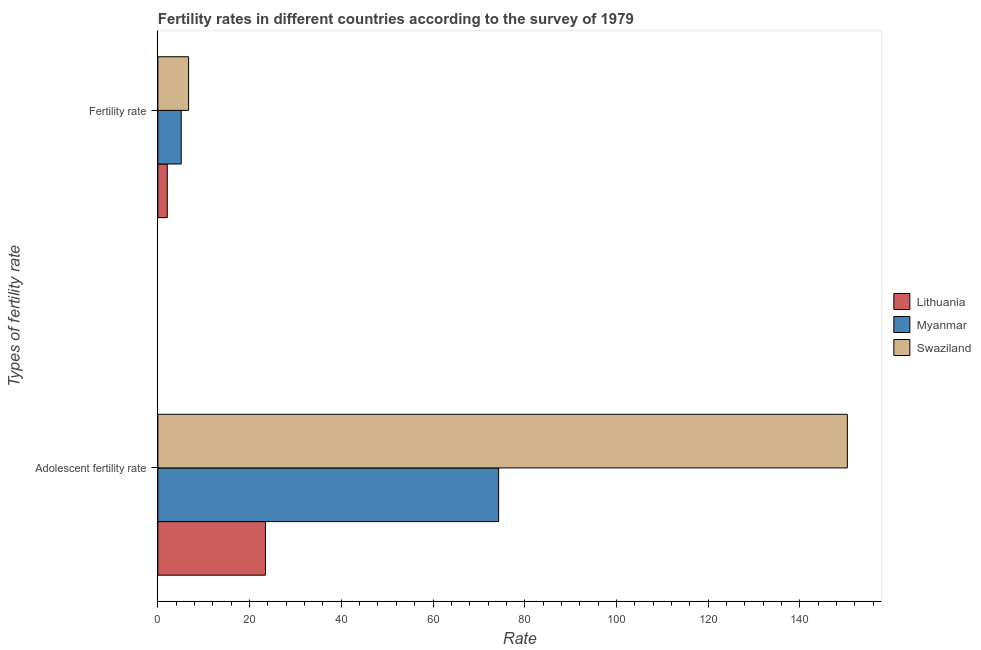How many groups of bars are there?
Provide a short and direct response. 2. Are the number of bars on each tick of the Y-axis equal?
Ensure brevity in your answer.  Yes. How many bars are there on the 1st tick from the top?
Provide a short and direct response. 3. How many bars are there on the 2nd tick from the bottom?
Ensure brevity in your answer.  3. What is the label of the 2nd group of bars from the top?
Offer a terse response. Adolescent fertility rate. What is the adolescent fertility rate in Lithuania?
Ensure brevity in your answer.  23.46. Across all countries, what is the maximum fertility rate?
Offer a very short reply. 6.7. Across all countries, what is the minimum adolescent fertility rate?
Offer a very short reply. 23.46. In which country was the fertility rate maximum?
Offer a very short reply. Swaziland. In which country was the adolescent fertility rate minimum?
Offer a terse response. Lithuania. What is the total adolescent fertility rate in the graph?
Your answer should be very brief. 248.12. What is the difference between the fertility rate in Swaziland and that in Lithuania?
Ensure brevity in your answer.  4.65. What is the difference between the adolescent fertility rate in Swaziland and the fertility rate in Lithuania?
Your answer should be compact. 148.31. What is the average fertility rate per country?
Give a very brief answer. 4.61. What is the difference between the fertility rate and adolescent fertility rate in Swaziland?
Provide a succinct answer. -143.67. In how many countries, is the fertility rate greater than 56 ?
Keep it short and to the point. 0. What is the ratio of the adolescent fertility rate in Myanmar to that in Swaziland?
Give a very brief answer. 0.49. In how many countries, is the fertility rate greater than the average fertility rate taken over all countries?
Provide a short and direct response. 2. What does the 2nd bar from the top in Adolescent fertility rate represents?
Offer a very short reply. Myanmar. What does the 2nd bar from the bottom in Adolescent fertility rate represents?
Provide a succinct answer. Myanmar. How many bars are there?
Your answer should be compact. 6. Are the values on the major ticks of X-axis written in scientific E-notation?
Your answer should be very brief. No. Does the graph contain any zero values?
Ensure brevity in your answer.  No. How many legend labels are there?
Offer a very short reply. 3. How are the legend labels stacked?
Your answer should be compact. Vertical. What is the title of the graph?
Your response must be concise. Fertility rates in different countries according to the survey of 1979. What is the label or title of the X-axis?
Your response must be concise. Rate. What is the label or title of the Y-axis?
Your response must be concise. Types of fertility rate. What is the Rate in Lithuania in Adolescent fertility rate?
Your answer should be compact. 23.46. What is the Rate of Myanmar in Adolescent fertility rate?
Your answer should be compact. 74.31. What is the Rate in Swaziland in Adolescent fertility rate?
Give a very brief answer. 150.36. What is the Rate in Lithuania in Fertility rate?
Make the answer very short. 2.05. What is the Rate in Myanmar in Fertility rate?
Keep it short and to the point. 5.09. What is the Rate of Swaziland in Fertility rate?
Your answer should be compact. 6.7. Across all Types of fertility rate, what is the maximum Rate of Lithuania?
Ensure brevity in your answer.  23.46. Across all Types of fertility rate, what is the maximum Rate in Myanmar?
Offer a very short reply. 74.31. Across all Types of fertility rate, what is the maximum Rate of Swaziland?
Give a very brief answer. 150.36. Across all Types of fertility rate, what is the minimum Rate of Lithuania?
Ensure brevity in your answer.  2.05. Across all Types of fertility rate, what is the minimum Rate of Myanmar?
Keep it short and to the point. 5.09. Across all Types of fertility rate, what is the minimum Rate of Swaziland?
Your answer should be very brief. 6.7. What is the total Rate of Lithuania in the graph?
Offer a terse response. 25.51. What is the total Rate of Myanmar in the graph?
Make the answer very short. 79.39. What is the total Rate in Swaziland in the graph?
Give a very brief answer. 157.06. What is the difference between the Rate in Lithuania in Adolescent fertility rate and that in Fertility rate?
Offer a very short reply. 21.41. What is the difference between the Rate in Myanmar in Adolescent fertility rate and that in Fertility rate?
Your answer should be very brief. 69.22. What is the difference between the Rate of Swaziland in Adolescent fertility rate and that in Fertility rate?
Provide a short and direct response. 143.67. What is the difference between the Rate of Lithuania in Adolescent fertility rate and the Rate of Myanmar in Fertility rate?
Offer a very short reply. 18.37. What is the difference between the Rate of Lithuania in Adolescent fertility rate and the Rate of Swaziland in Fertility rate?
Ensure brevity in your answer.  16.76. What is the difference between the Rate of Myanmar in Adolescent fertility rate and the Rate of Swaziland in Fertility rate?
Ensure brevity in your answer.  67.61. What is the average Rate of Lithuania per Types of fertility rate?
Ensure brevity in your answer.  12.75. What is the average Rate in Myanmar per Types of fertility rate?
Offer a terse response. 39.7. What is the average Rate of Swaziland per Types of fertility rate?
Provide a succinct answer. 78.53. What is the difference between the Rate in Lithuania and Rate in Myanmar in Adolescent fertility rate?
Offer a very short reply. -50.85. What is the difference between the Rate of Lithuania and Rate of Swaziland in Adolescent fertility rate?
Provide a succinct answer. -126.91. What is the difference between the Rate in Myanmar and Rate in Swaziland in Adolescent fertility rate?
Ensure brevity in your answer.  -76.06. What is the difference between the Rate of Lithuania and Rate of Myanmar in Fertility rate?
Give a very brief answer. -3.04. What is the difference between the Rate of Lithuania and Rate of Swaziland in Fertility rate?
Your response must be concise. -4.64. What is the difference between the Rate in Myanmar and Rate in Swaziland in Fertility rate?
Offer a very short reply. -1.61. What is the ratio of the Rate in Lithuania in Adolescent fertility rate to that in Fertility rate?
Your answer should be compact. 11.44. What is the ratio of the Rate in Myanmar in Adolescent fertility rate to that in Fertility rate?
Your response must be concise. 14.61. What is the ratio of the Rate in Swaziland in Adolescent fertility rate to that in Fertility rate?
Make the answer very short. 22.46. What is the difference between the highest and the second highest Rate of Lithuania?
Give a very brief answer. 21.41. What is the difference between the highest and the second highest Rate in Myanmar?
Give a very brief answer. 69.22. What is the difference between the highest and the second highest Rate of Swaziland?
Your answer should be compact. 143.67. What is the difference between the highest and the lowest Rate in Lithuania?
Ensure brevity in your answer.  21.41. What is the difference between the highest and the lowest Rate in Myanmar?
Your response must be concise. 69.22. What is the difference between the highest and the lowest Rate of Swaziland?
Your answer should be very brief. 143.67. 